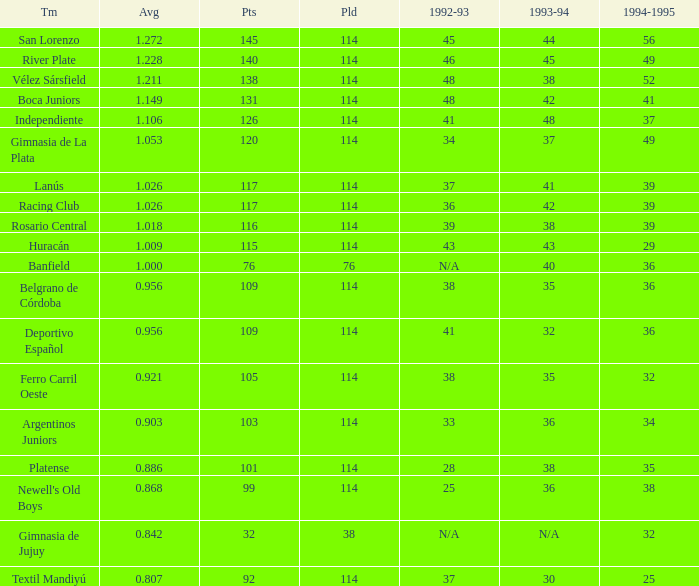Name the total number of 1992-93 for 115 points 1.0. Can you parse all the data within this table? {'header': ['Tm', 'Avg', 'Pts', 'Pld', '1992-93', '1993-94', '1994-1995'], 'rows': [['San Lorenzo', '1.272', '145', '114', '45', '44', '56'], ['River Plate', '1.228', '140', '114', '46', '45', '49'], ['Vélez Sársfield', '1.211', '138', '114', '48', '38', '52'], ['Boca Juniors', '1.149', '131', '114', '48', '42', '41'], ['Independiente', '1.106', '126', '114', '41', '48', '37'], ['Gimnasia de La Plata', '1.053', '120', '114', '34', '37', '49'], ['Lanús', '1.026', '117', '114', '37', '41', '39'], ['Racing Club', '1.026', '117', '114', '36', '42', '39'], ['Rosario Central', '1.018', '116', '114', '39', '38', '39'], ['Huracán', '1.009', '115', '114', '43', '43', '29'], ['Banfield', '1.000', '76', '76', 'N/A', '40', '36'], ['Belgrano de Córdoba', '0.956', '109', '114', '38', '35', '36'], ['Deportivo Español', '0.956', '109', '114', '41', '32', '36'], ['Ferro Carril Oeste', '0.921', '105', '114', '38', '35', '32'], ['Argentinos Juniors', '0.903', '103', '114', '33', '36', '34'], ['Platense', '0.886', '101', '114', '28', '38', '35'], ["Newell's Old Boys", '0.868', '99', '114', '25', '36', '38'], ['Gimnasia de Jujuy', '0.842', '32', '38', 'N/A', 'N/A', '32'], ['Textil Mandiyú', '0.807', '92', '114', '37', '30', '25']]} 